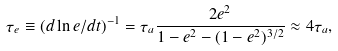Convert formula to latex. <formula><loc_0><loc_0><loc_500><loc_500>\tau _ { e } \equiv ( d \ln e / d t ) ^ { - 1 } = \tau _ { a } \frac { 2 e ^ { 2 } } { 1 - e ^ { 2 } - ( 1 - e ^ { 2 } ) ^ { 3 / 2 } } \approx 4 \tau _ { a } ,</formula> 